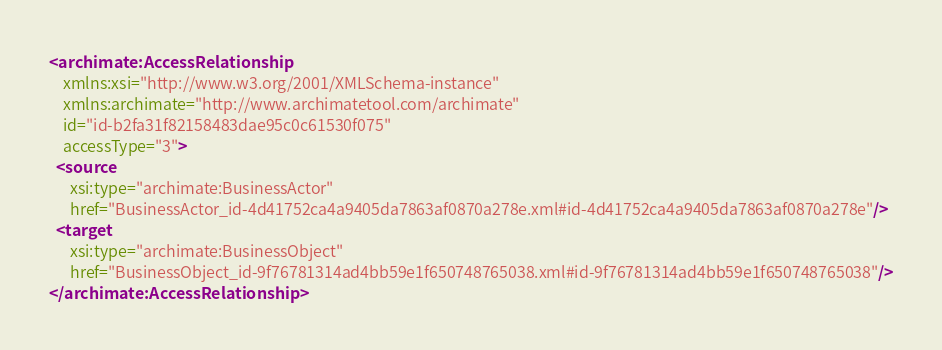<code> <loc_0><loc_0><loc_500><loc_500><_XML_><archimate:AccessRelationship
    xmlns:xsi="http://www.w3.org/2001/XMLSchema-instance"
    xmlns:archimate="http://www.archimatetool.com/archimate"
    id="id-b2fa31f82158483dae95c0c61530f075"
    accessType="3">
  <source
      xsi:type="archimate:BusinessActor"
      href="BusinessActor_id-4d41752ca4a9405da7863af0870a278e.xml#id-4d41752ca4a9405da7863af0870a278e"/>
  <target
      xsi:type="archimate:BusinessObject"
      href="BusinessObject_id-9f76781314ad4bb59e1f650748765038.xml#id-9f76781314ad4bb59e1f650748765038"/>
</archimate:AccessRelationship>
</code> 